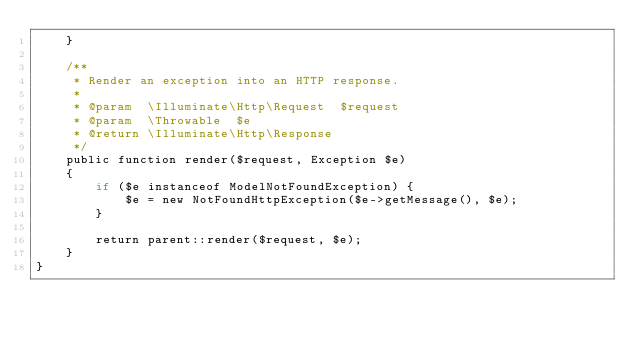<code> <loc_0><loc_0><loc_500><loc_500><_PHP_>    }

    /**
     * Render an exception into an HTTP response.
     *
     * @param  \Illuminate\Http\Request  $request
     * @param  \Throwable  $e
     * @return \Illuminate\Http\Response
     */
    public function render($request, Exception $e)
    {
        if ($e instanceof ModelNotFoundException) {
            $e = new NotFoundHttpException($e->getMessage(), $e);
        }

        return parent::render($request, $e);
    }
}
</code> 